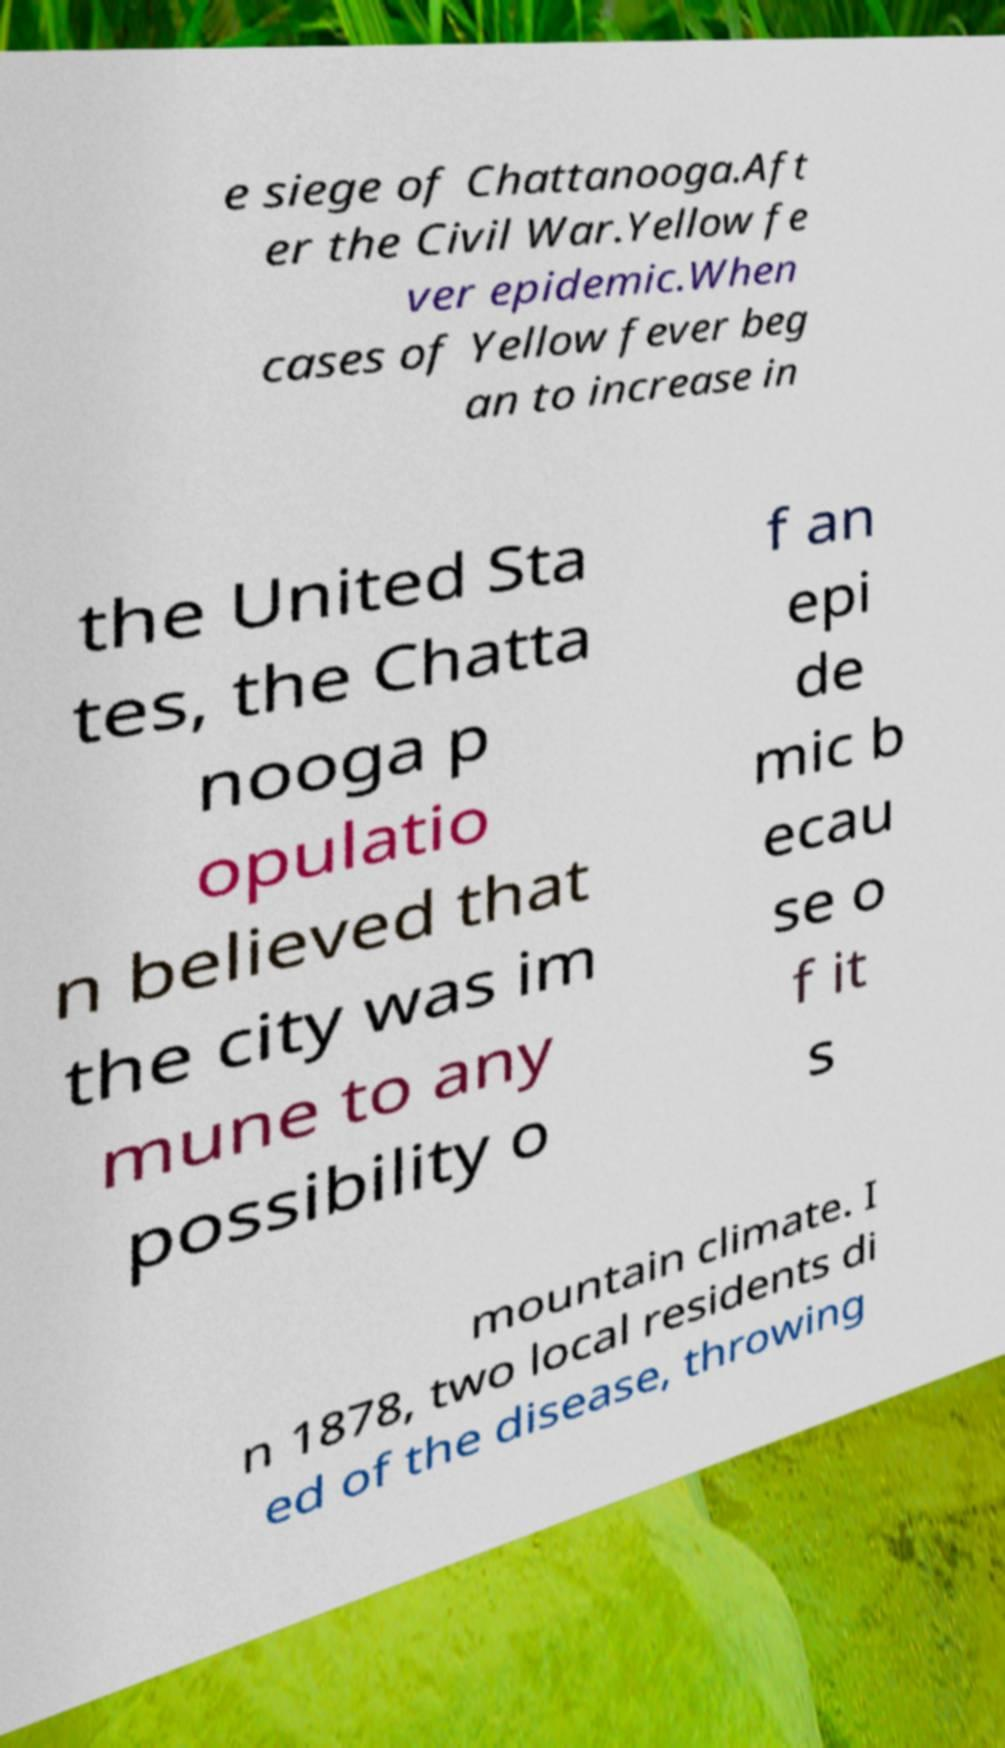Please identify and transcribe the text found in this image. e siege of Chattanooga.Aft er the Civil War.Yellow fe ver epidemic.When cases of Yellow fever beg an to increase in the United Sta tes, the Chatta nooga p opulatio n believed that the city was im mune to any possibility o f an epi de mic b ecau se o f it s mountain climate. I n 1878, two local residents di ed of the disease, throwing 